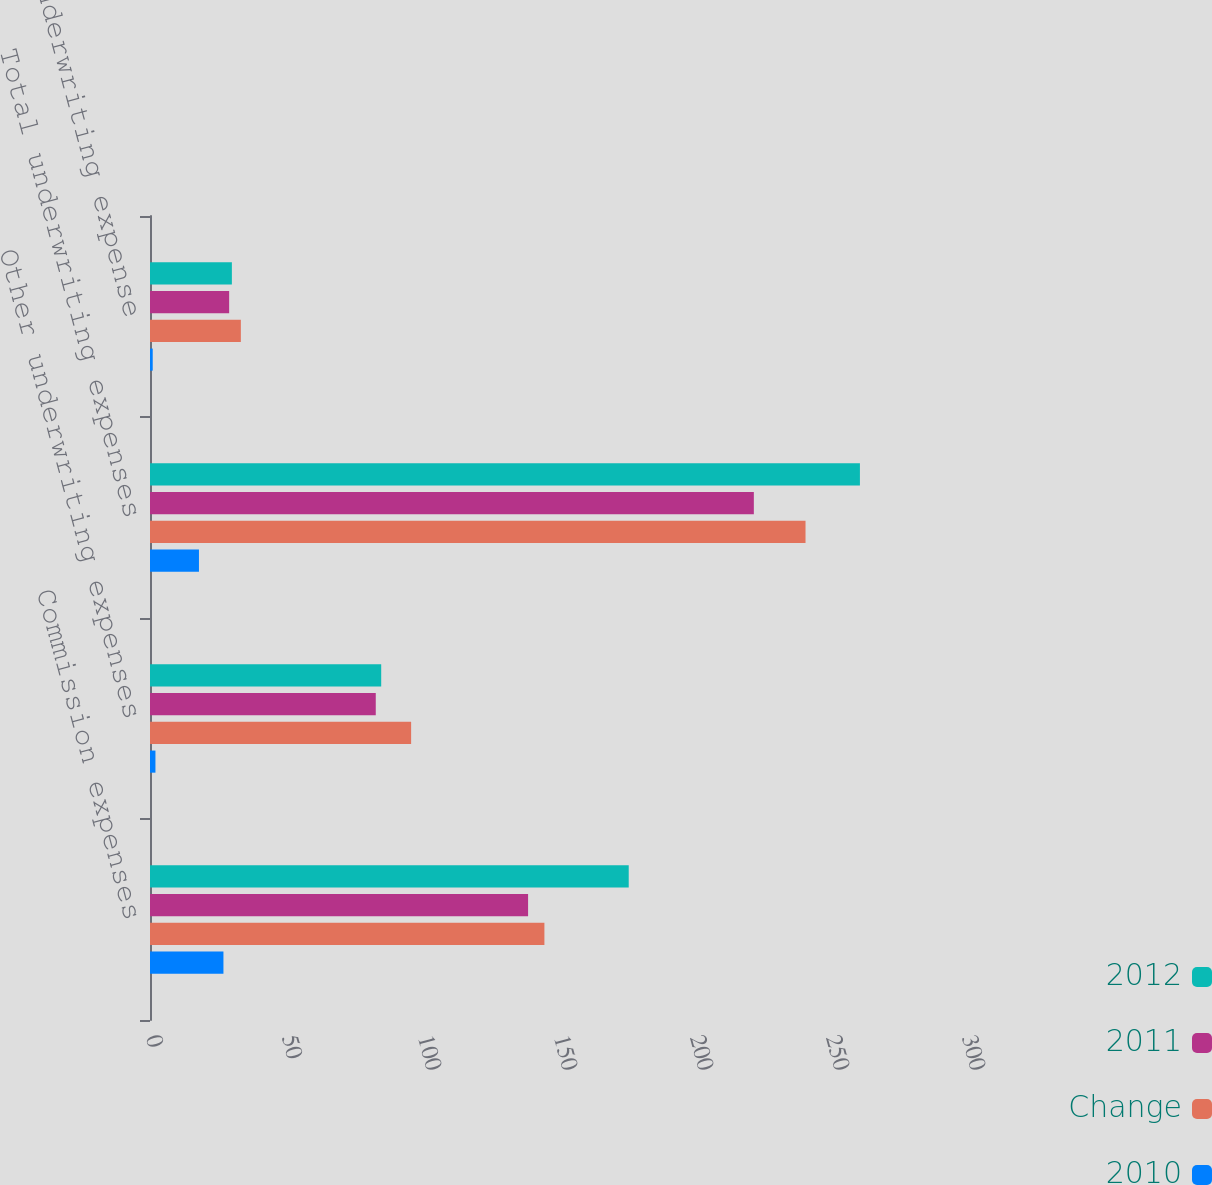Convert chart to OTSL. <chart><loc_0><loc_0><loc_500><loc_500><stacked_bar_chart><ecel><fcel>Commission expenses<fcel>Other underwriting expenses<fcel>Total underwriting expenses<fcel>Total underwriting expense<nl><fcel>2012<fcel>176<fcel>85<fcel>261<fcel>30.1<nl><fcel>2011<fcel>139<fcel>83<fcel>222<fcel>29.1<nl><fcel>Change<fcel>145<fcel>96<fcel>241<fcel>33.4<nl><fcel>2010<fcel>27<fcel>2<fcel>18<fcel>1<nl></chart> 